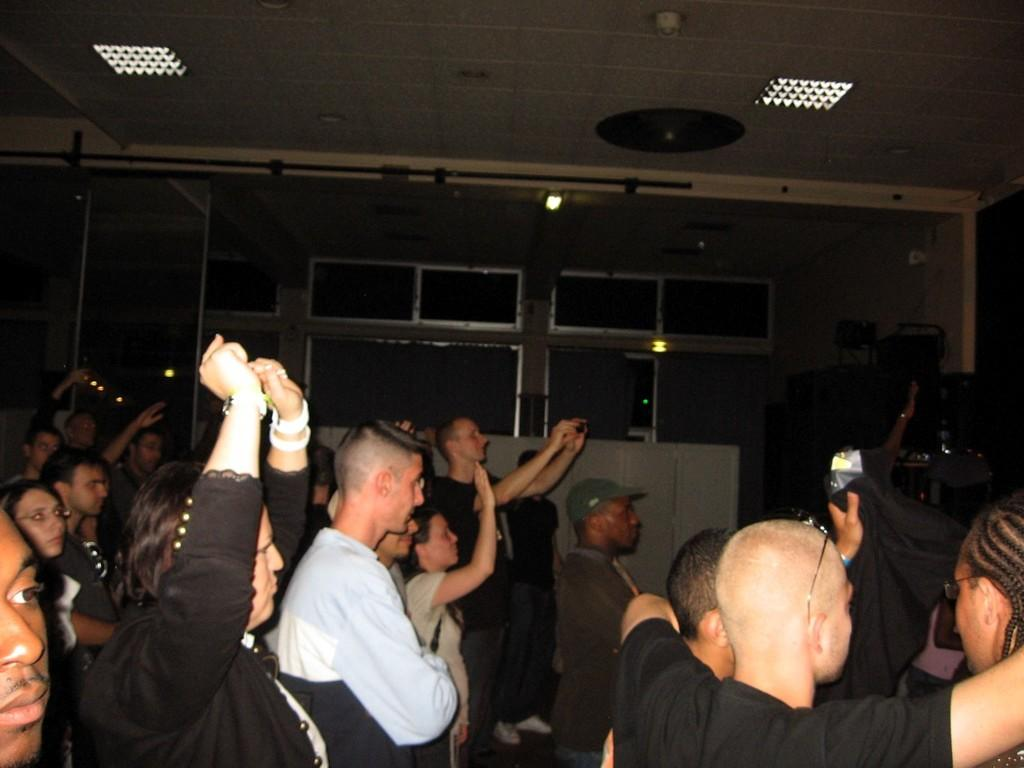What are the people in the image doing? The people in the image are standing on a wall. Can you describe the gender of the people in the image? There are men and women in the image. What can be seen in the background of the image? There are windows and a wall in the background of the image. What is the level of the cloud in the image? There is no cloud present in the image, so it is not possible to determine the level of a cloud. 